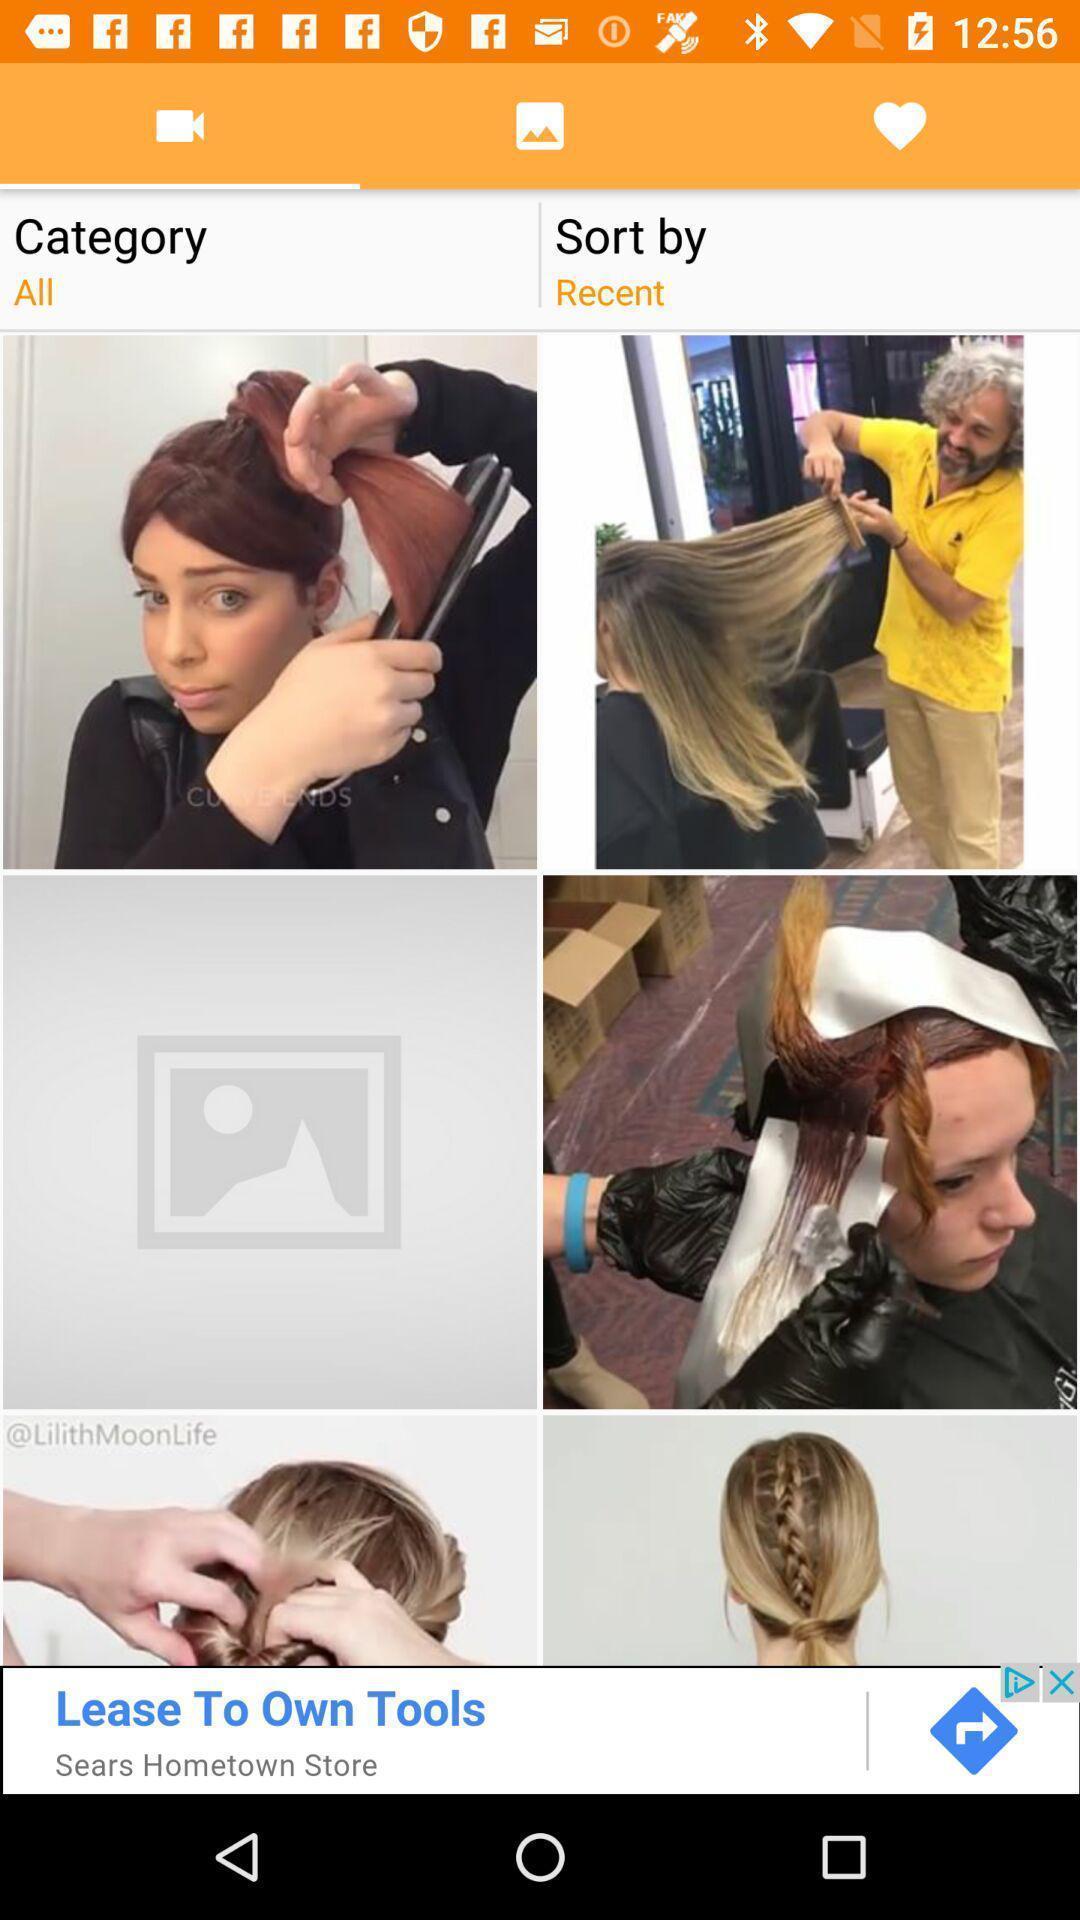Provide a detailed account of this screenshot. Screen displaying videos page for hair styles. 